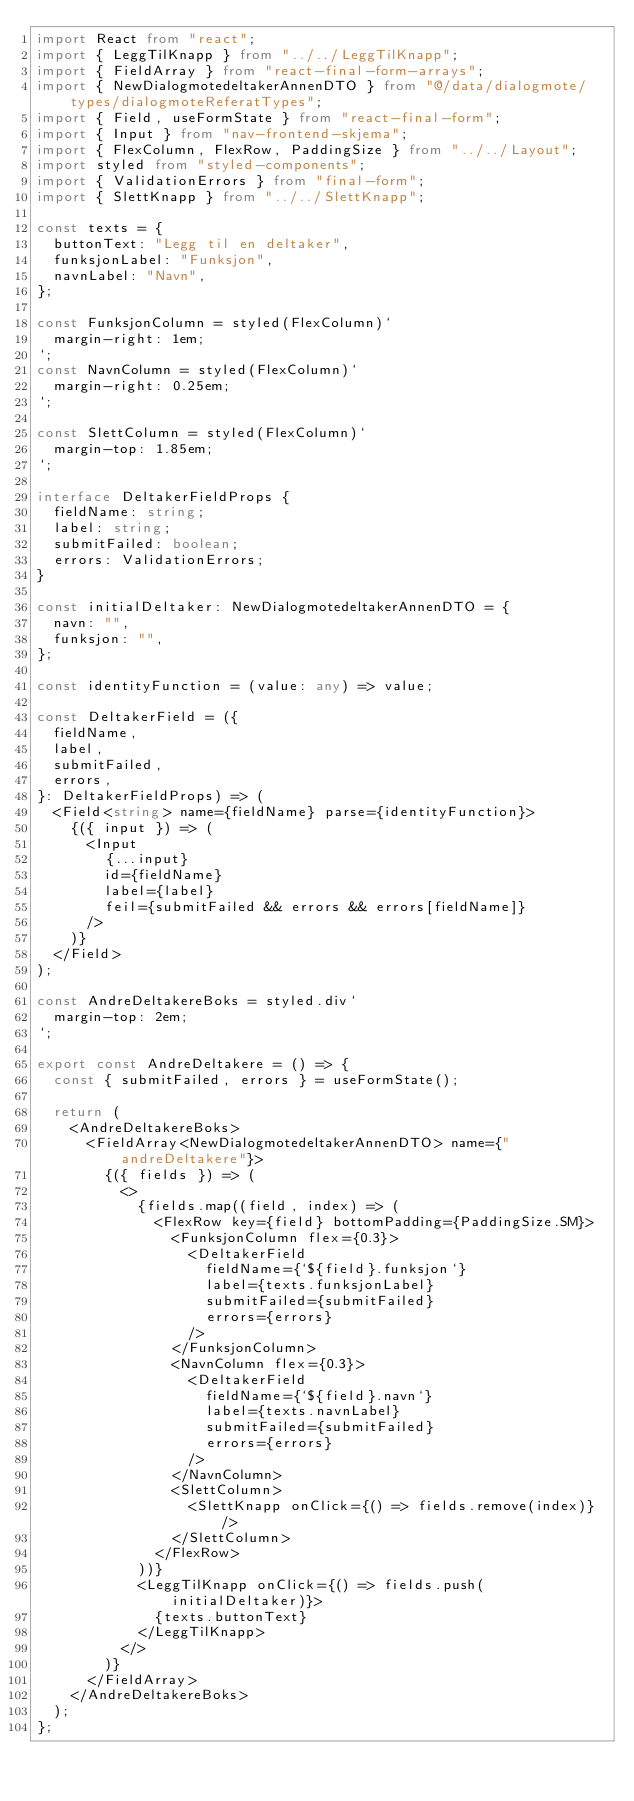<code> <loc_0><loc_0><loc_500><loc_500><_TypeScript_>import React from "react";
import { LeggTilKnapp } from "../../LeggTilKnapp";
import { FieldArray } from "react-final-form-arrays";
import { NewDialogmotedeltakerAnnenDTO } from "@/data/dialogmote/types/dialogmoteReferatTypes";
import { Field, useFormState } from "react-final-form";
import { Input } from "nav-frontend-skjema";
import { FlexColumn, FlexRow, PaddingSize } from "../../Layout";
import styled from "styled-components";
import { ValidationErrors } from "final-form";
import { SlettKnapp } from "../../SlettKnapp";

const texts = {
  buttonText: "Legg til en deltaker",
  funksjonLabel: "Funksjon",
  navnLabel: "Navn",
};

const FunksjonColumn = styled(FlexColumn)`
  margin-right: 1em;
`;
const NavnColumn = styled(FlexColumn)`
  margin-right: 0.25em;
`;

const SlettColumn = styled(FlexColumn)`
  margin-top: 1.85em;
`;

interface DeltakerFieldProps {
  fieldName: string;
  label: string;
  submitFailed: boolean;
  errors: ValidationErrors;
}

const initialDeltaker: NewDialogmotedeltakerAnnenDTO = {
  navn: "",
  funksjon: "",
};

const identityFunction = (value: any) => value;

const DeltakerField = ({
  fieldName,
  label,
  submitFailed,
  errors,
}: DeltakerFieldProps) => (
  <Field<string> name={fieldName} parse={identityFunction}>
    {({ input }) => (
      <Input
        {...input}
        id={fieldName}
        label={label}
        feil={submitFailed && errors && errors[fieldName]}
      />
    )}
  </Field>
);

const AndreDeltakereBoks = styled.div`
  margin-top: 2em;
`;

export const AndreDeltakere = () => {
  const { submitFailed, errors } = useFormState();

  return (
    <AndreDeltakereBoks>
      <FieldArray<NewDialogmotedeltakerAnnenDTO> name={"andreDeltakere"}>
        {({ fields }) => (
          <>
            {fields.map((field, index) => (
              <FlexRow key={field} bottomPadding={PaddingSize.SM}>
                <FunksjonColumn flex={0.3}>
                  <DeltakerField
                    fieldName={`${field}.funksjon`}
                    label={texts.funksjonLabel}
                    submitFailed={submitFailed}
                    errors={errors}
                  />
                </FunksjonColumn>
                <NavnColumn flex={0.3}>
                  <DeltakerField
                    fieldName={`${field}.navn`}
                    label={texts.navnLabel}
                    submitFailed={submitFailed}
                    errors={errors}
                  />
                </NavnColumn>
                <SlettColumn>
                  <SlettKnapp onClick={() => fields.remove(index)} />
                </SlettColumn>
              </FlexRow>
            ))}
            <LeggTilKnapp onClick={() => fields.push(initialDeltaker)}>
              {texts.buttonText}
            </LeggTilKnapp>
          </>
        )}
      </FieldArray>
    </AndreDeltakereBoks>
  );
};
</code> 